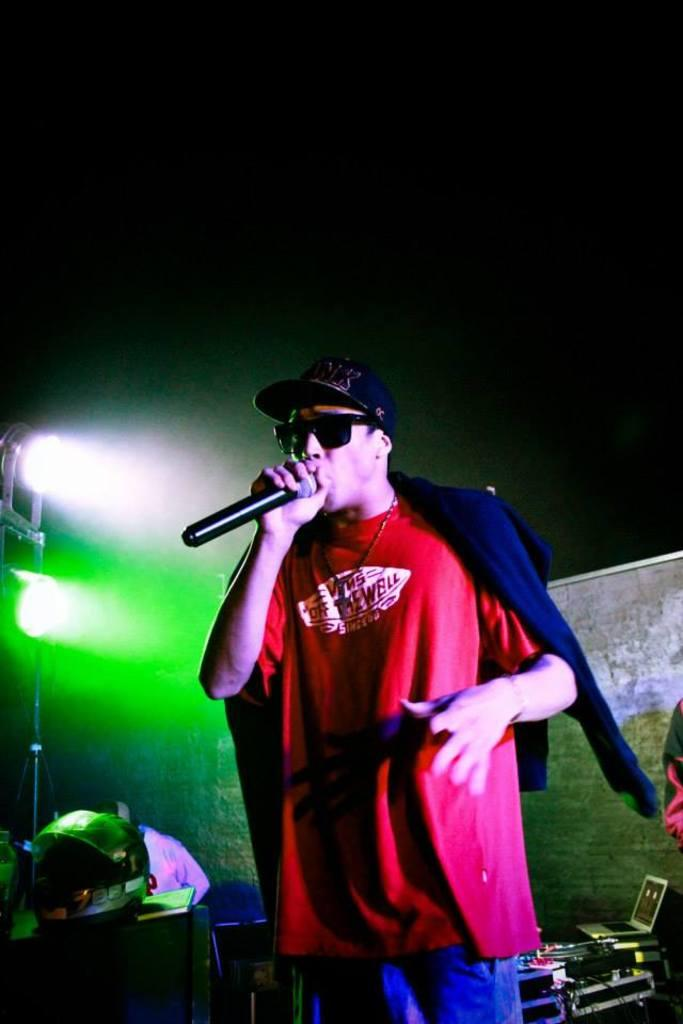What is the person on the stage doing? The person is standing on the stage. What object is the person holding? The person is holding a microphone. What type of headwear is the person wearing? The person is wearing a cap. What type of eyewear is the person wearing? The person is wearing spectacles. Can you see a kitten brushing its fur on the stage? There is no kitten or brush present in the image; it only features a person standing on the stage holding a microphone. 